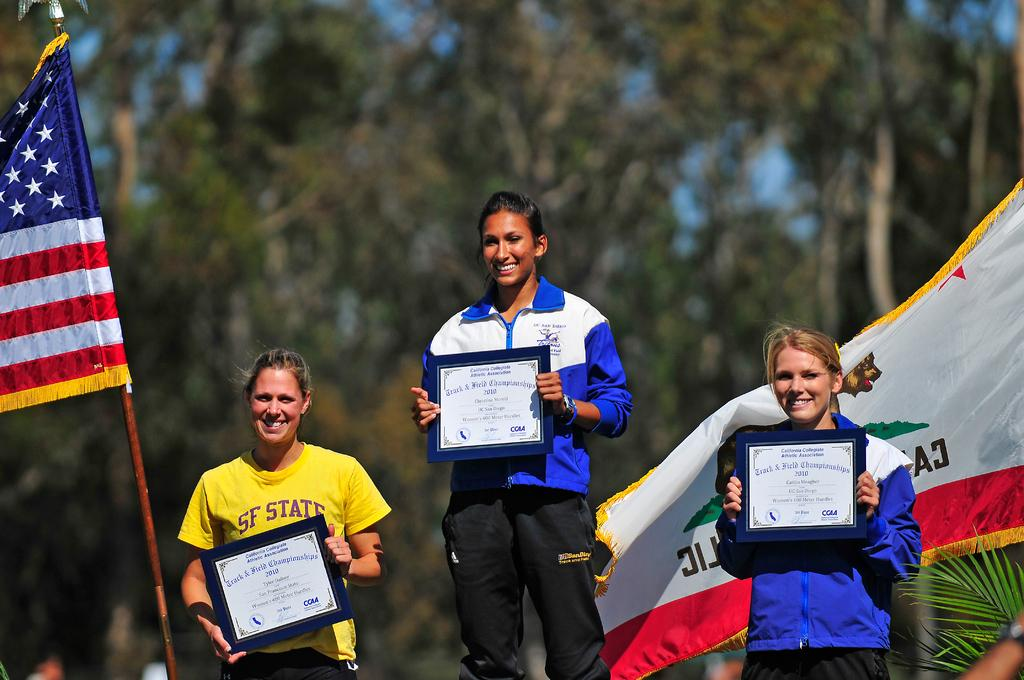How many women are in the image? There are three women in the image. What are the women doing in the image? The women are standing in the image. What are the women holding in the image? The women are holding certifications in the image. What can be seen in the background of the image? There are trees in the background of the image. Where is the decision made in the image? There is no mention of a decision being made in the image. Can you see a pocket in the image? There is no pocket visible in the image. 